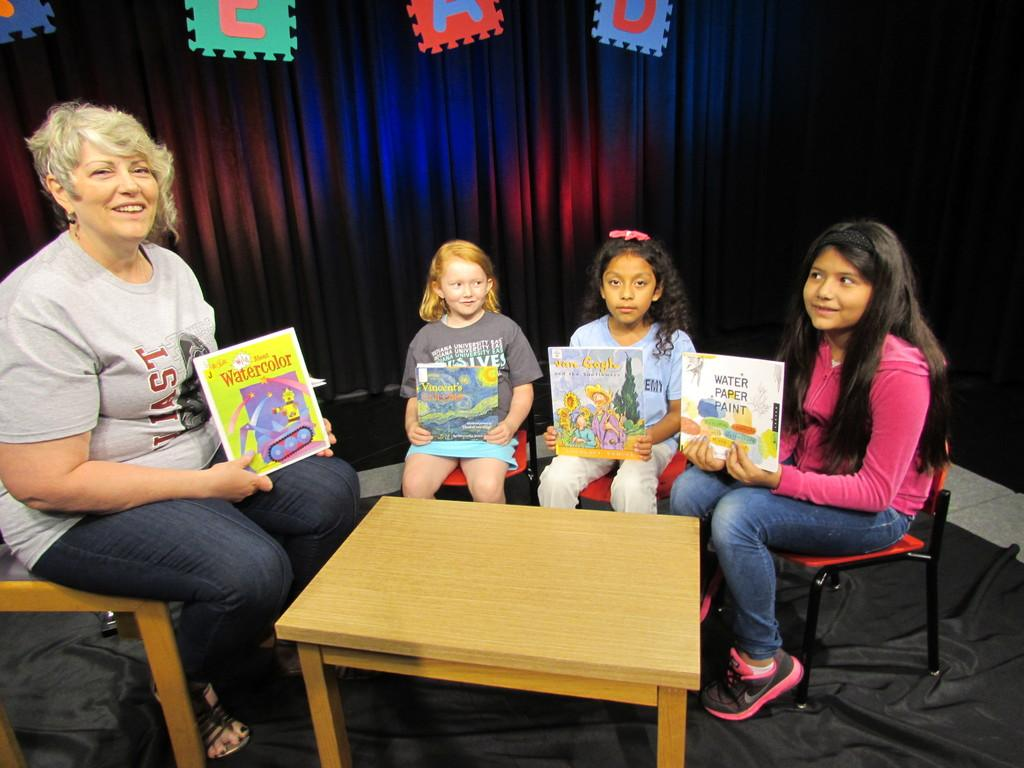What are the kids doing in the image? The kids are sitting on a chair and holding books. What is the woman doing in the image? The woman is sitting on a chair and holding a book. What is present in front of the person in the image? There is a table in front of the person. Can you see a clam in the image? No, there is no clam present in the image. Where is the nest located in the image? There is no nest present in the image. 